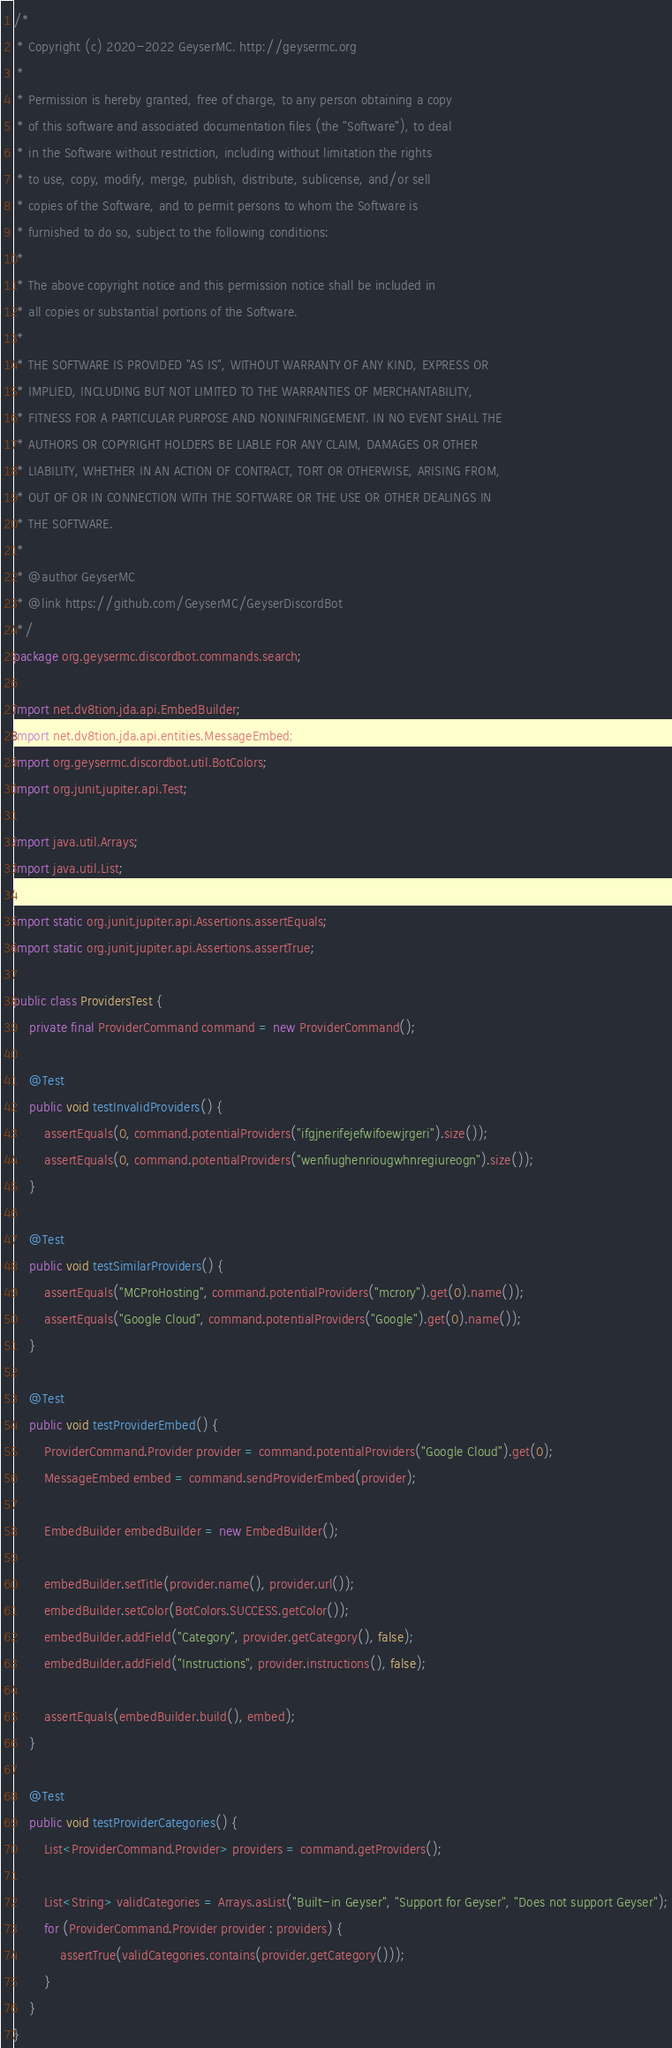<code> <loc_0><loc_0><loc_500><loc_500><_Java_>/*
 * Copyright (c) 2020-2022 GeyserMC. http://geysermc.org
 *
 * Permission is hereby granted, free of charge, to any person obtaining a copy
 * of this software and associated documentation files (the "Software"), to deal
 * in the Software without restriction, including without limitation the rights
 * to use, copy, modify, merge, publish, distribute, sublicense, and/or sell
 * copies of the Software, and to permit persons to whom the Software is
 * furnished to do so, subject to the following conditions:
 *
 * The above copyright notice and this permission notice shall be included in
 * all copies or substantial portions of the Software.
 *
 * THE SOFTWARE IS PROVIDED "AS IS", WITHOUT WARRANTY OF ANY KIND, EXPRESS OR
 * IMPLIED, INCLUDING BUT NOT LIMITED TO THE WARRANTIES OF MERCHANTABILITY,
 * FITNESS FOR A PARTICULAR PURPOSE AND NONINFRINGEMENT. IN NO EVENT SHALL THE
 * AUTHORS OR COPYRIGHT HOLDERS BE LIABLE FOR ANY CLAIM, DAMAGES OR OTHER
 * LIABILITY, WHETHER IN AN ACTION OF CONTRACT, TORT OR OTHERWISE, ARISING FROM,
 * OUT OF OR IN CONNECTION WITH THE SOFTWARE OR THE USE OR OTHER DEALINGS IN
 * THE SOFTWARE.
 *
 * @author GeyserMC
 * @link https://github.com/GeyserMC/GeyserDiscordBot
 */
package org.geysermc.discordbot.commands.search;

import net.dv8tion.jda.api.EmbedBuilder;
import net.dv8tion.jda.api.entities.MessageEmbed;
import org.geysermc.discordbot.util.BotColors;
import org.junit.jupiter.api.Test;

import java.util.Arrays;
import java.util.List;

import static org.junit.jupiter.api.Assertions.assertEquals;
import static org.junit.jupiter.api.Assertions.assertTrue;

public class ProvidersTest {
    private final ProviderCommand command = new ProviderCommand();

    @Test
    public void testInvalidProviders() {
        assertEquals(0, command.potentialProviders("ifgjnerifejefwifoewjrgeri").size());
        assertEquals(0, command.potentialProviders("wenfiughenriougwhnregiureogn").size());
    }

    @Test
    public void testSimilarProviders() {
        assertEquals("MCProHosting", command.potentialProviders("mcrory").get(0).name());
        assertEquals("Google Cloud", command.potentialProviders("Google").get(0).name());
    }

    @Test
    public void testProviderEmbed() {
        ProviderCommand.Provider provider = command.potentialProviders("Google Cloud").get(0);
        MessageEmbed embed = command.sendProviderEmbed(provider);

        EmbedBuilder embedBuilder = new EmbedBuilder();

        embedBuilder.setTitle(provider.name(), provider.url());
        embedBuilder.setColor(BotColors.SUCCESS.getColor());
        embedBuilder.addField("Category", provider.getCategory(), false);
        embedBuilder.addField("Instructions", provider.instructions(), false);

        assertEquals(embedBuilder.build(), embed);
    }

    @Test
    public void testProviderCategories() {
        List<ProviderCommand.Provider> providers = command.getProviders();

        List<String> validCategories = Arrays.asList("Built-in Geyser", "Support for Geyser", "Does not support Geyser");
        for (ProviderCommand.Provider provider : providers) {
            assertTrue(validCategories.contains(provider.getCategory()));
        }
    }
}
</code> 